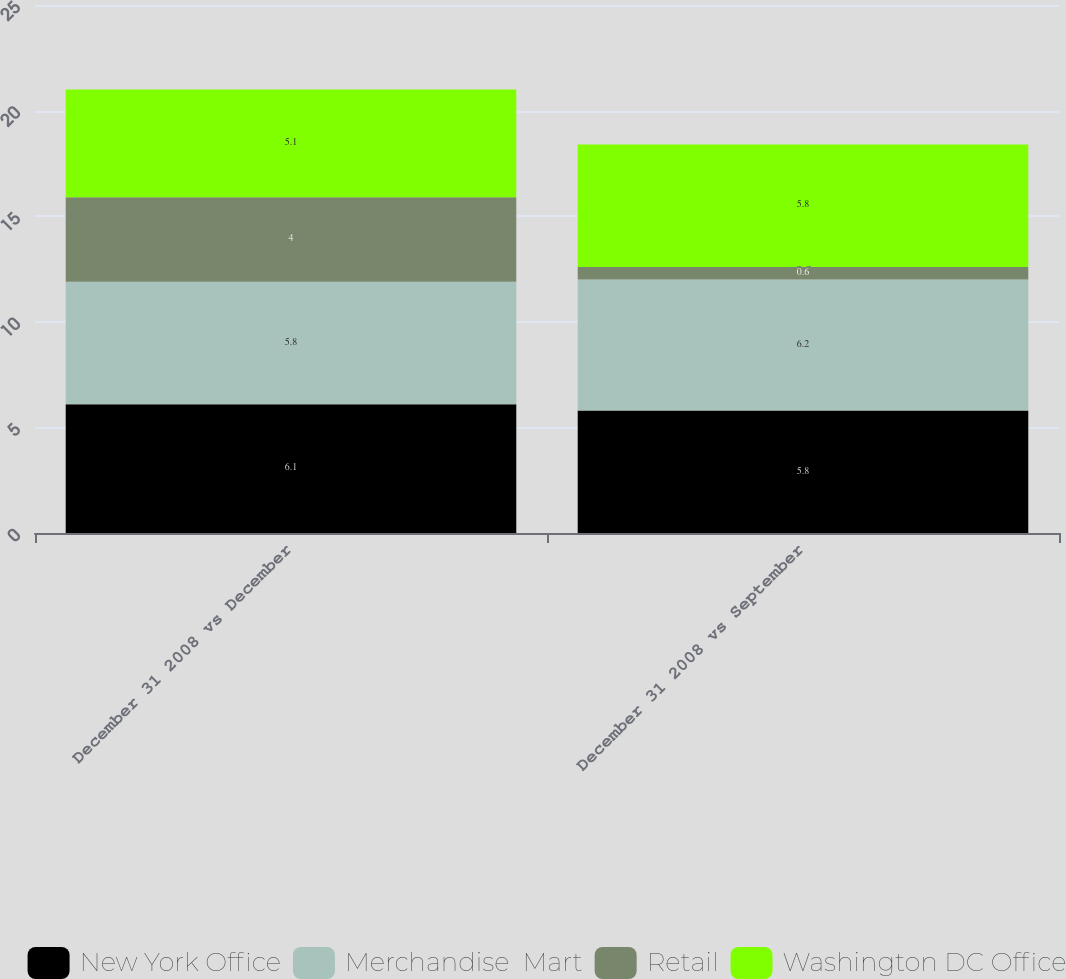Convert chart. <chart><loc_0><loc_0><loc_500><loc_500><stacked_bar_chart><ecel><fcel>December 31 2008 vs December<fcel>December 31 2008 vs September<nl><fcel>New York Office<fcel>6.1<fcel>5.8<nl><fcel>Merchandise  Mart<fcel>5.8<fcel>6.2<nl><fcel>Retail<fcel>4<fcel>0.6<nl><fcel>Washington DC Office<fcel>5.1<fcel>5.8<nl></chart> 